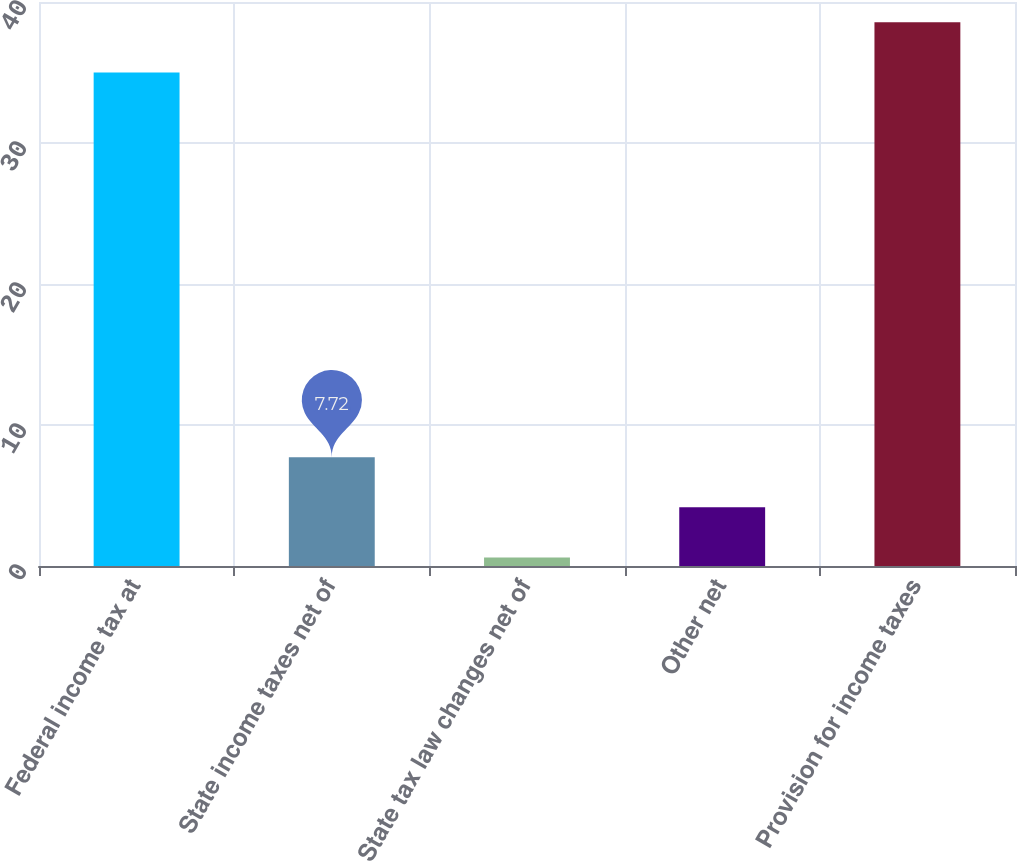Convert chart. <chart><loc_0><loc_0><loc_500><loc_500><bar_chart><fcel>Federal income tax at<fcel>State income taxes net of<fcel>State tax law changes net of<fcel>Other net<fcel>Provision for income taxes<nl><fcel>35<fcel>7.72<fcel>0.6<fcel>4.16<fcel>38.56<nl></chart> 